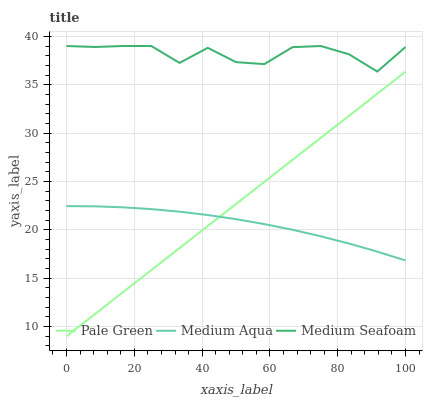Does Medium Aqua have the minimum area under the curve?
Answer yes or no. Yes. Does Medium Seafoam have the maximum area under the curve?
Answer yes or no. Yes. Does Medium Seafoam have the minimum area under the curve?
Answer yes or no. No. Does Medium Aqua have the maximum area under the curve?
Answer yes or no. No. Is Pale Green the smoothest?
Answer yes or no. Yes. Is Medium Seafoam the roughest?
Answer yes or no. Yes. Is Medium Aqua the smoothest?
Answer yes or no. No. Is Medium Aqua the roughest?
Answer yes or no. No. Does Pale Green have the lowest value?
Answer yes or no. Yes. Does Medium Aqua have the lowest value?
Answer yes or no. No. Does Medium Seafoam have the highest value?
Answer yes or no. Yes. Does Medium Aqua have the highest value?
Answer yes or no. No. Is Pale Green less than Medium Seafoam?
Answer yes or no. Yes. Is Medium Seafoam greater than Medium Aqua?
Answer yes or no. Yes. Does Medium Aqua intersect Pale Green?
Answer yes or no. Yes. Is Medium Aqua less than Pale Green?
Answer yes or no. No. Is Medium Aqua greater than Pale Green?
Answer yes or no. No. Does Pale Green intersect Medium Seafoam?
Answer yes or no. No. 